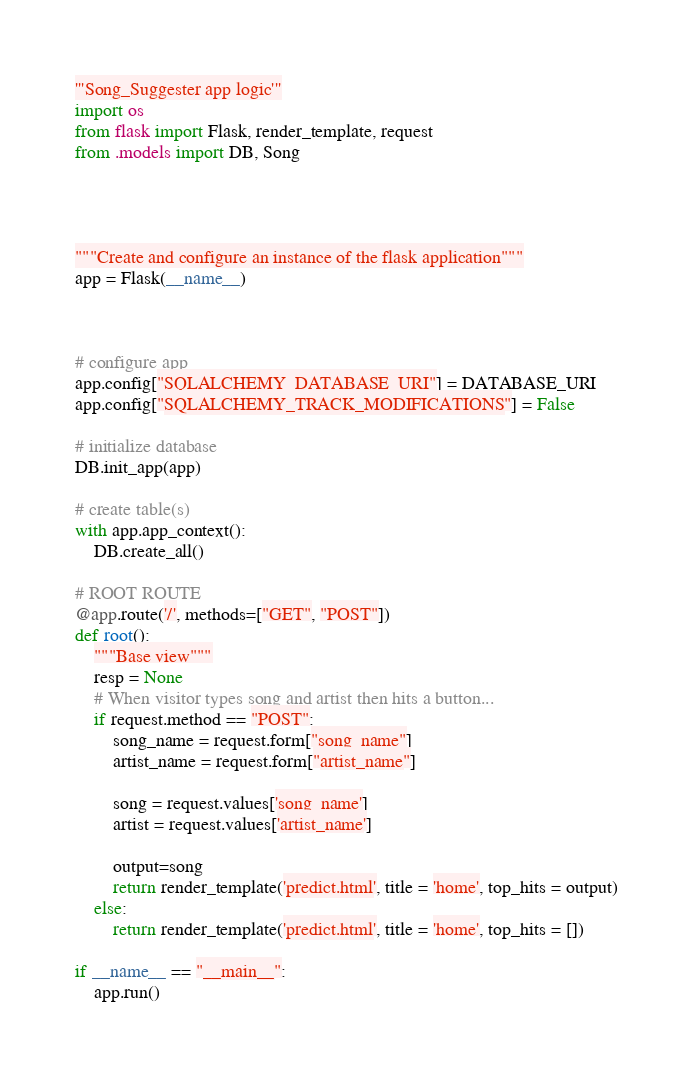<code> <loc_0><loc_0><loc_500><loc_500><_Python_>'''Song_Suggester app logic'''
import os
from flask import Flask, render_template, request
from .models import DB, Song




"""Create and configure an instance of the flask application"""
app = Flask(__name__)



# configure app
app.config["SQLALCHEMY_DATABASE_URI"] = DATABASE_URI
app.config["SQLALCHEMY_TRACK_MODIFICATIONS"] = False

# initialize database
DB.init_app(app)

# create table(s)
with app.app_context():
    DB.create_all()

# ROOT ROUTE
@app.route('/', methods=["GET", "POST"])
def root():     
    """Base view"""
    resp = None
    # When visitor types song and artist then hits a button...
    if request.method == "POST":
        song_name = request.form["song_name"]
        artist_name = request.form["artist_name"]

        song = request.values['song_name']
        artist = request.values['artist_name']

        output=song
        return render_template('predict.html', title = 'home', top_hits = output) 
    else: 
        return render_template('predict.html', title = 'home', top_hits = [])

if __name__ == "__main__":
    app.run()
</code> 